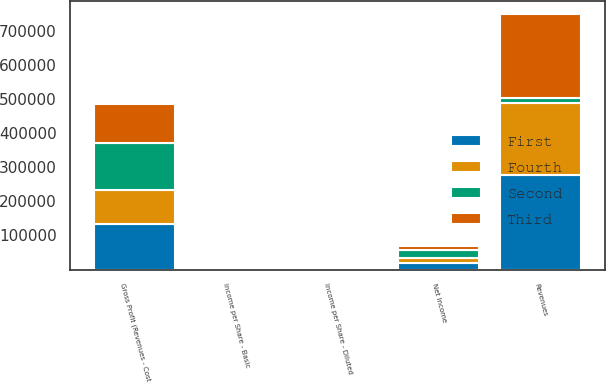<chart> <loc_0><loc_0><loc_500><loc_500><stacked_bar_chart><ecel><fcel>Revenues<fcel>Gross Profit (Revenues - Cost<fcel>Net Income<fcel>Income per Share - Basic<fcel>Income per Share - Diluted<nl><fcel>Fourth<fcel>210078<fcel>100125<fcel>13839<fcel>0.14<fcel>0.14<nl><fcel>Second<fcel>13839<fcel>138423<fcel>22738<fcel>0.23<fcel>0.23<nl><fcel>First<fcel>277911<fcel>132496<fcel>19804<fcel>0.2<fcel>0.2<nl><fcel>Third<fcel>248076<fcel>115026<fcel>12553<fcel>0.13<fcel>0.13<nl></chart> 